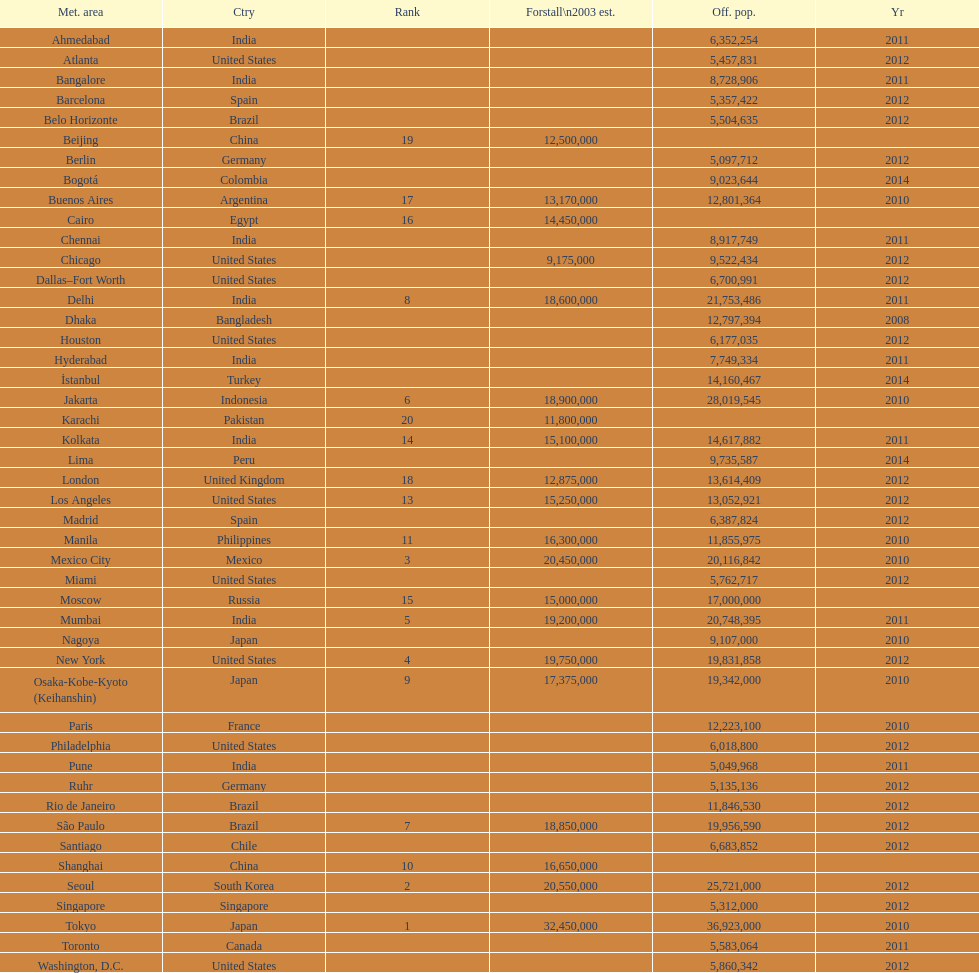Would you mind parsing the complete table? {'header': ['Met. area', 'Ctry', 'Rank', 'Forstall\\n2003 est.', 'Off. pop.', 'Yr'], 'rows': [['Ahmedabad', 'India', '', '', '6,352,254', '2011'], ['Atlanta', 'United States', '', '', '5,457,831', '2012'], ['Bangalore', 'India', '', '', '8,728,906', '2011'], ['Barcelona', 'Spain', '', '', '5,357,422', '2012'], ['Belo Horizonte', 'Brazil', '', '', '5,504,635', '2012'], ['Beijing', 'China', '19', '12,500,000', '', ''], ['Berlin', 'Germany', '', '', '5,097,712', '2012'], ['Bogotá', 'Colombia', '', '', '9,023,644', '2014'], ['Buenos Aires', 'Argentina', '17', '13,170,000', '12,801,364', '2010'], ['Cairo', 'Egypt', '16', '14,450,000', '', ''], ['Chennai', 'India', '', '', '8,917,749', '2011'], ['Chicago', 'United States', '', '9,175,000', '9,522,434', '2012'], ['Dallas–Fort Worth', 'United States', '', '', '6,700,991', '2012'], ['Delhi', 'India', '8', '18,600,000', '21,753,486', '2011'], ['Dhaka', 'Bangladesh', '', '', '12,797,394', '2008'], ['Houston', 'United States', '', '', '6,177,035', '2012'], ['Hyderabad', 'India', '', '', '7,749,334', '2011'], ['İstanbul', 'Turkey', '', '', '14,160,467', '2014'], ['Jakarta', 'Indonesia', '6', '18,900,000', '28,019,545', '2010'], ['Karachi', 'Pakistan', '20', '11,800,000', '', ''], ['Kolkata', 'India', '14', '15,100,000', '14,617,882', '2011'], ['Lima', 'Peru', '', '', '9,735,587', '2014'], ['London', 'United Kingdom', '18', '12,875,000', '13,614,409', '2012'], ['Los Angeles', 'United States', '13', '15,250,000', '13,052,921', '2012'], ['Madrid', 'Spain', '', '', '6,387,824', '2012'], ['Manila', 'Philippines', '11', '16,300,000', '11,855,975', '2010'], ['Mexico City', 'Mexico', '3', '20,450,000', '20,116,842', '2010'], ['Miami', 'United States', '', '', '5,762,717', '2012'], ['Moscow', 'Russia', '15', '15,000,000', '17,000,000', ''], ['Mumbai', 'India', '5', '19,200,000', '20,748,395', '2011'], ['Nagoya', 'Japan', '', '', '9,107,000', '2010'], ['New York', 'United States', '4', '19,750,000', '19,831,858', '2012'], ['Osaka-Kobe-Kyoto (Keihanshin)', 'Japan', '9', '17,375,000', '19,342,000', '2010'], ['Paris', 'France', '', '', '12,223,100', '2010'], ['Philadelphia', 'United States', '', '', '6,018,800', '2012'], ['Pune', 'India', '', '', '5,049,968', '2011'], ['Ruhr', 'Germany', '', '', '5,135,136', '2012'], ['Rio de Janeiro', 'Brazil', '', '', '11,846,530', '2012'], ['São Paulo', 'Brazil', '7', '18,850,000', '19,956,590', '2012'], ['Santiago', 'Chile', '', '', '6,683,852', '2012'], ['Shanghai', 'China', '10', '16,650,000', '', ''], ['Seoul', 'South Korea', '2', '20,550,000', '25,721,000', '2012'], ['Singapore', 'Singapore', '', '', '5,312,000', '2012'], ['Tokyo', 'Japan', '1', '32,450,000', '36,923,000', '2010'], ['Toronto', 'Canada', '', '', '5,583,064', '2011'], ['Washington, D.C.', 'United States', '', '', '5,860,342', '2012']]} Which area is listed above chicago? Chennai. 